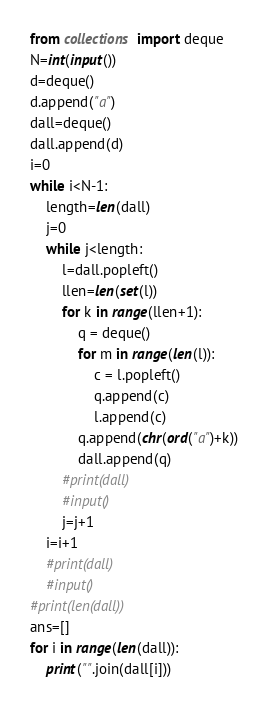Convert code to text. <code><loc_0><loc_0><loc_500><loc_500><_Python_>from collections import deque
N=int(input())
d=deque()
d.append("a")
dall=deque()
dall.append(d)
i=0
while i<N-1:
    length=len(dall)
    j=0
    while j<length:
        l=dall.popleft()
        llen=len(set(l))
        for k in range(llen+1):
            q = deque()
            for m in range(len(l)):
                c = l.popleft()
                q.append(c)
                l.append(c)
            q.append(chr(ord("a")+k))
            dall.append(q)
        #print(dall)
        #input()
        j=j+1
    i=i+1
    #print(dall)
    #input()
#print(len(dall))
ans=[]
for i in range(len(dall)):
    print("".join(dall[i]))</code> 